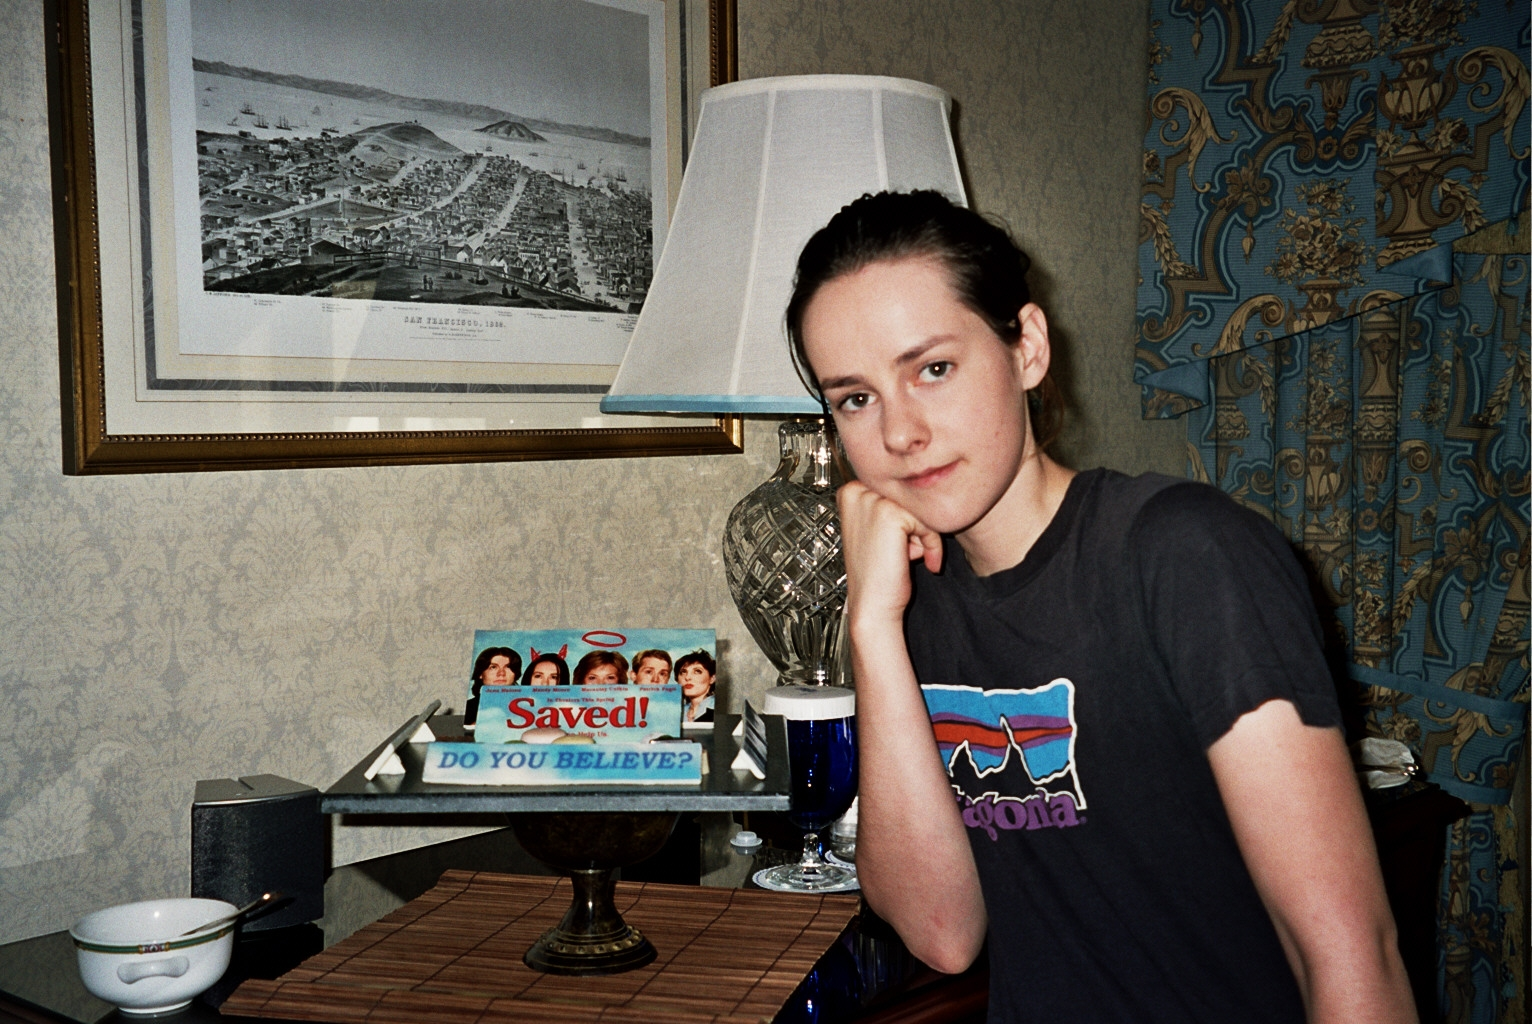Write a short poem inspired by this image. In a room where memories cling,
A teacup sits, stories to bring.
A lamp's glow, soft and warm,
Guides the thoughts that gently swarm.
Old cityscapes on walls they climb,
Whispers of a bygone time.
Here she rests in quiet grace,
A tranquil heart, a thoughtful face. 